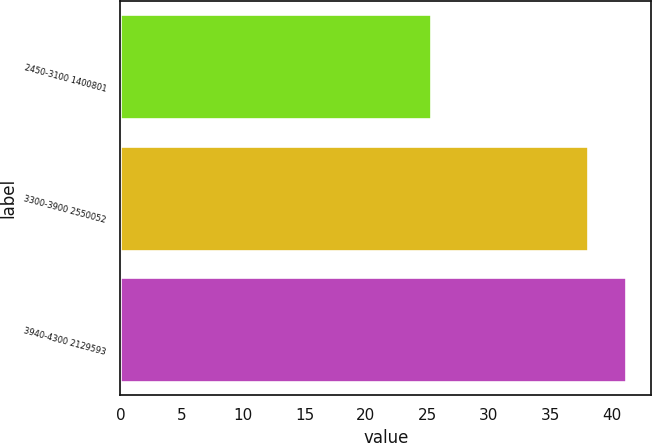<chart> <loc_0><loc_0><loc_500><loc_500><bar_chart><fcel>2450-3100 1400801<fcel>3300-3900 2550052<fcel>3940-4300 2129593<nl><fcel>25.32<fcel>38.09<fcel>41.17<nl></chart> 